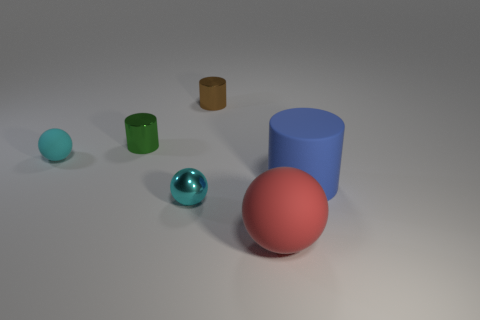Add 1 small brown matte things. How many objects exist? 7 Add 6 cyan matte things. How many cyan matte things are left? 7 Add 3 big brown rubber things. How many big brown rubber things exist? 3 Subtract 0 blue spheres. How many objects are left? 6 Subtract all green metallic things. Subtract all small cyan matte spheres. How many objects are left? 4 